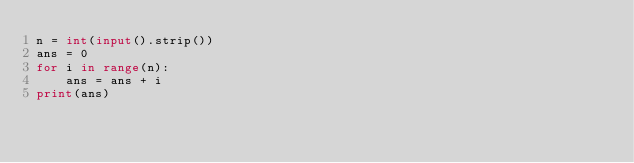<code> <loc_0><loc_0><loc_500><loc_500><_Python_>n = int(input().strip())
ans = 0
for i in range(n):
    ans = ans + i
print(ans)
</code> 